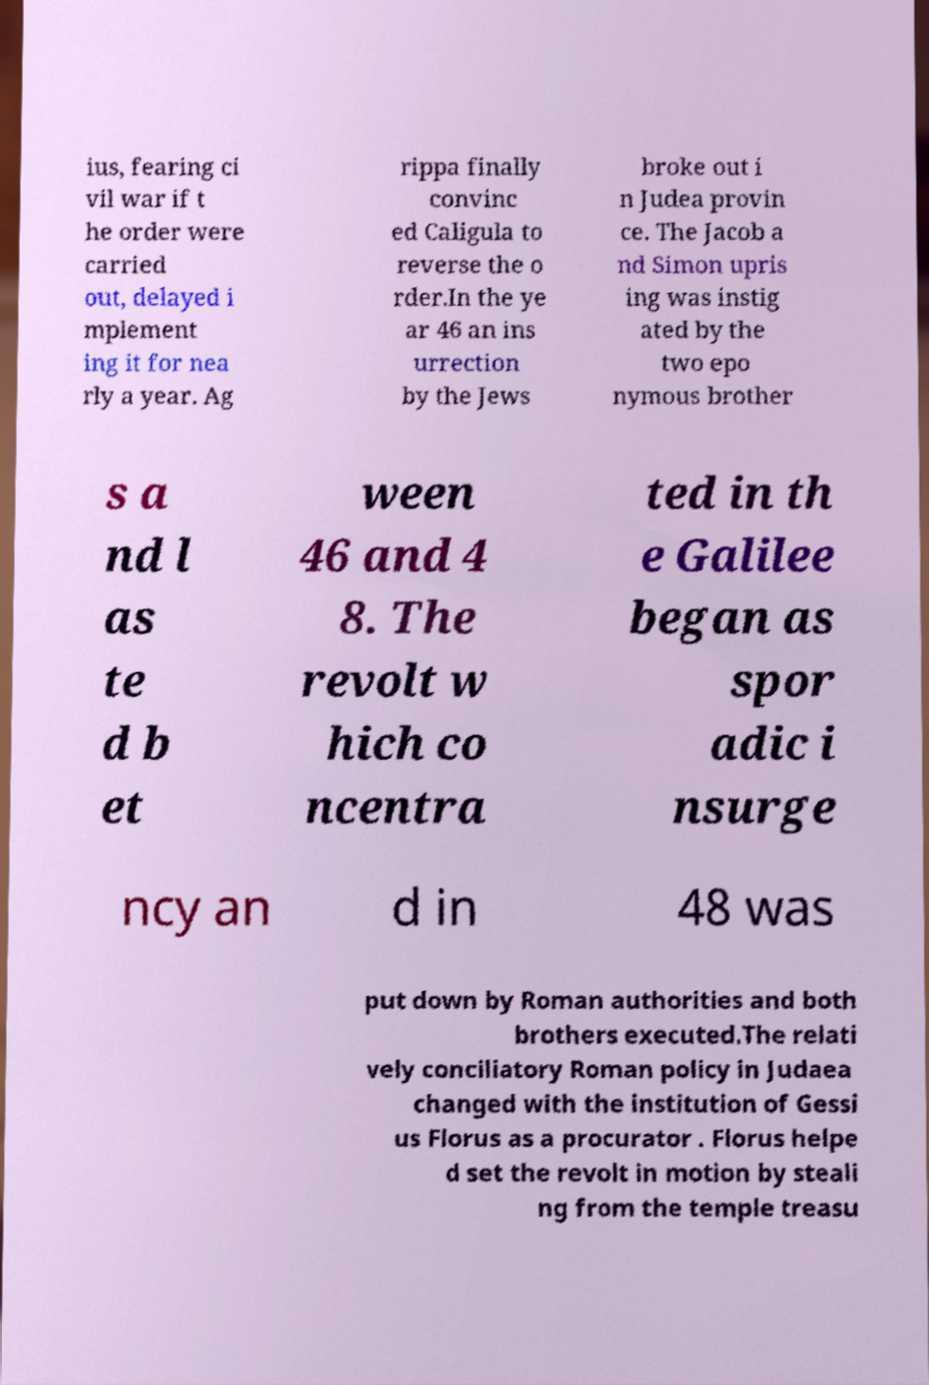Could you extract and type out the text from this image? ius, fearing ci vil war if t he order were carried out, delayed i mplement ing it for nea rly a year. Ag rippa finally convinc ed Caligula to reverse the o rder.In the ye ar 46 an ins urrection by the Jews broke out i n Judea provin ce. The Jacob a nd Simon upris ing was instig ated by the two epo nymous brother s a nd l as te d b et ween 46 and 4 8. The revolt w hich co ncentra ted in th e Galilee began as spor adic i nsurge ncy an d in 48 was put down by Roman authorities and both brothers executed.The relati vely conciliatory Roman policy in Judaea changed with the institution of Gessi us Florus as a procurator . Florus helpe d set the revolt in motion by steali ng from the temple treasu 